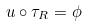<formula> <loc_0><loc_0><loc_500><loc_500>u \circ \tau _ { R } = \phi</formula> 